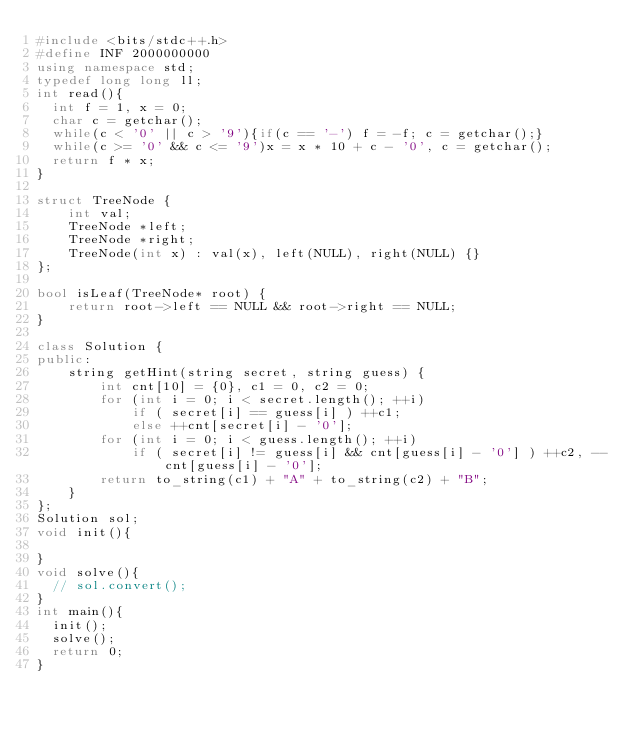Convert code to text. <code><loc_0><loc_0><loc_500><loc_500><_C++_>#include <bits/stdc++.h>
#define INF 2000000000
using namespace std;
typedef long long ll;
int read(){
	int f = 1, x = 0;
	char c = getchar();
	while(c < '0' || c > '9'){if(c == '-') f = -f; c = getchar();}
	while(c >= '0' && c <= '9')x = x * 10 + c - '0', c = getchar();
	return f * x; 
}

struct TreeNode {
    int val;
    TreeNode *left;
    TreeNode *right;
    TreeNode(int x) : val(x), left(NULL), right(NULL) {}
};

bool isLeaf(TreeNode* root) {
    return root->left == NULL && root->right == NULL;
}

class Solution {
public:
    string getHint(string secret, string guess) {
        int cnt[10] = {0}, c1 = 0, c2 = 0;
        for (int i = 0; i < secret.length(); ++i)
            if ( secret[i] == guess[i] ) ++c1;
            else ++cnt[secret[i] - '0'];
        for (int i = 0; i < guess.length(); ++i)
            if ( secret[i] != guess[i] && cnt[guess[i] - '0'] ) ++c2, --cnt[guess[i] - '0'];
        return to_string(c1) + "A" + to_string(c2) + "B";
    }
};
Solution sol;
void init(){
    
}
void solve(){
	// sol.convert();
}
int main(){
	init();
	solve();
	return 0;
}
</code> 